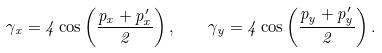Convert formula to latex. <formula><loc_0><loc_0><loc_500><loc_500>\gamma _ { x } = 4 \cos \left ( \frac { p _ { x } + p ^ { \prime } _ { x } } { 2 } \right ) , \quad \gamma _ { y } = 4 \cos \left ( \frac { p _ { y } + p ^ { \prime } _ { y } } { 2 } \right ) .</formula> 